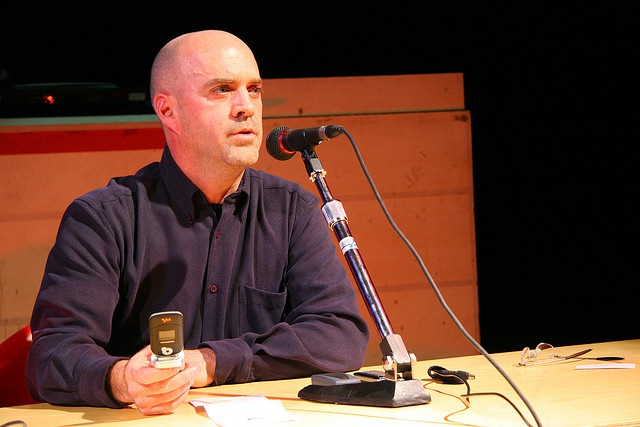Describe the objects in this image and their specific colors. I can see people in black and purple tones, cell phone in black, maroon, ivory, and brown tones, and chair in black, maroon, and brown tones in this image. 